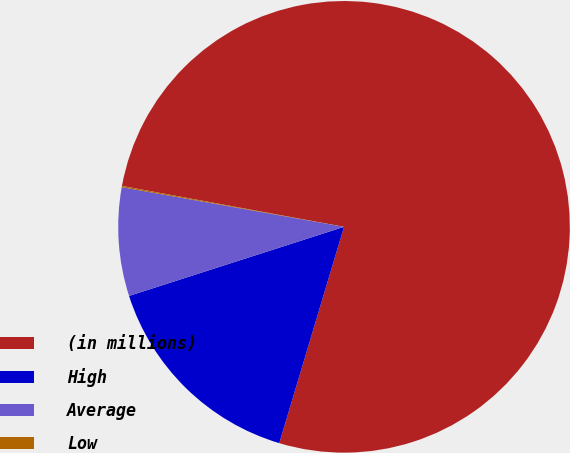Convert chart. <chart><loc_0><loc_0><loc_500><loc_500><pie_chart><fcel>(in millions)<fcel>High<fcel>Average<fcel>Low<nl><fcel>76.73%<fcel>15.42%<fcel>7.76%<fcel>0.09%<nl></chart> 